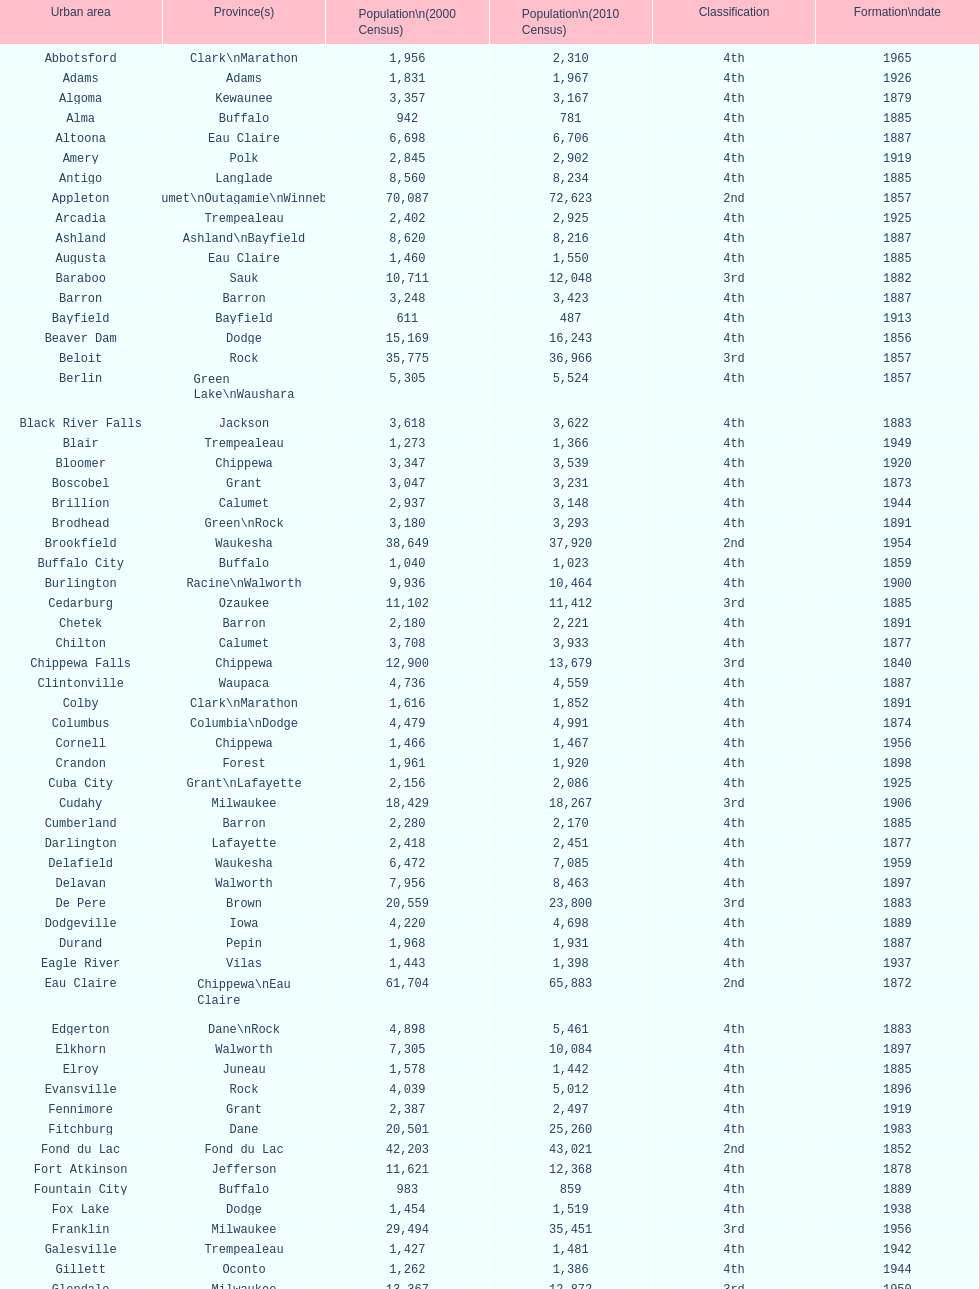Which city has the most population in the 2010 census? Milwaukee. 